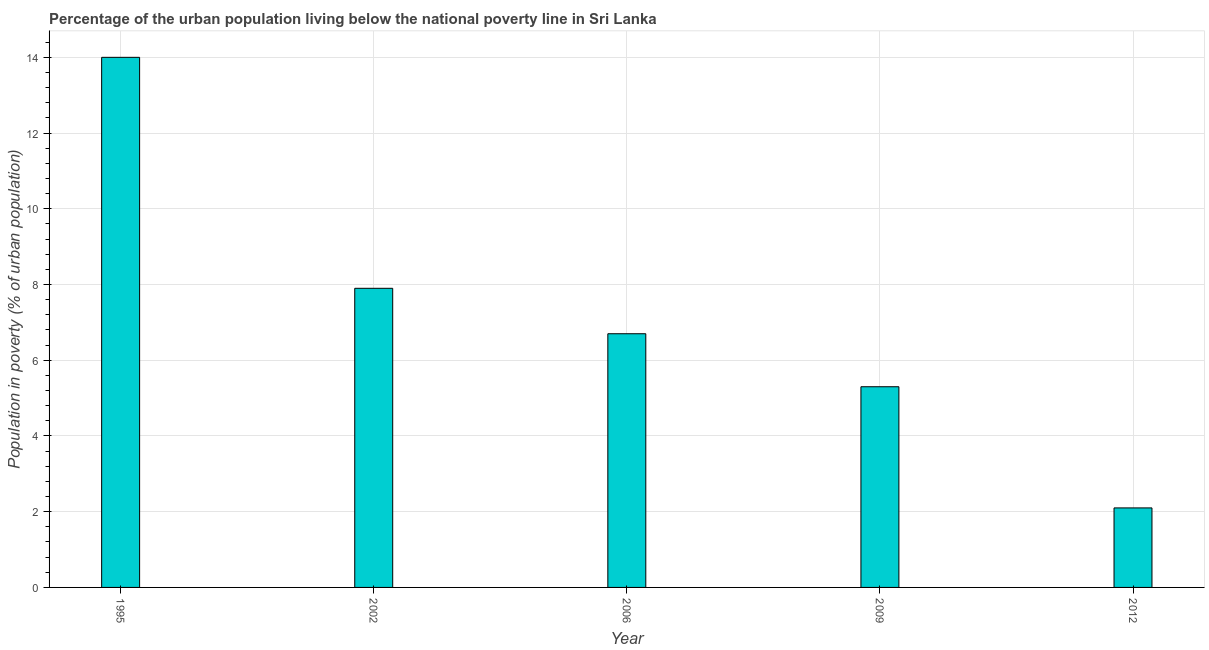What is the title of the graph?
Ensure brevity in your answer.  Percentage of the urban population living below the national poverty line in Sri Lanka. What is the label or title of the Y-axis?
Give a very brief answer. Population in poverty (% of urban population). What is the percentage of urban population living below poverty line in 2002?
Give a very brief answer. 7.9. Across all years, what is the maximum percentage of urban population living below poverty line?
Offer a terse response. 14. In which year was the percentage of urban population living below poverty line maximum?
Offer a very short reply. 1995. In which year was the percentage of urban population living below poverty line minimum?
Your response must be concise. 2012. What is the sum of the percentage of urban population living below poverty line?
Provide a succinct answer. 36. What is the median percentage of urban population living below poverty line?
Your response must be concise. 6.7. What is the ratio of the percentage of urban population living below poverty line in 2002 to that in 2009?
Keep it short and to the point. 1.49. Is the percentage of urban population living below poverty line in 1995 less than that in 2009?
Your answer should be very brief. No. Is the difference between the percentage of urban population living below poverty line in 2009 and 2012 greater than the difference between any two years?
Offer a terse response. No. What is the difference between the highest and the second highest percentage of urban population living below poverty line?
Make the answer very short. 6.1. Is the sum of the percentage of urban population living below poverty line in 2006 and 2009 greater than the maximum percentage of urban population living below poverty line across all years?
Provide a succinct answer. No. In how many years, is the percentage of urban population living below poverty line greater than the average percentage of urban population living below poverty line taken over all years?
Your answer should be very brief. 2. Are the values on the major ticks of Y-axis written in scientific E-notation?
Your response must be concise. No. What is the Population in poverty (% of urban population) of 1995?
Your answer should be very brief. 14. What is the Population in poverty (% of urban population) in 2002?
Ensure brevity in your answer.  7.9. What is the Population in poverty (% of urban population) in 2012?
Keep it short and to the point. 2.1. What is the difference between the Population in poverty (% of urban population) in 1995 and 2002?
Your answer should be compact. 6.1. What is the difference between the Population in poverty (% of urban population) in 1995 and 2006?
Make the answer very short. 7.3. What is the difference between the Population in poverty (% of urban population) in 1995 and 2009?
Give a very brief answer. 8.7. What is the difference between the Population in poverty (% of urban population) in 1995 and 2012?
Provide a short and direct response. 11.9. What is the difference between the Population in poverty (% of urban population) in 2002 and 2006?
Keep it short and to the point. 1.2. What is the difference between the Population in poverty (% of urban population) in 2006 and 2009?
Give a very brief answer. 1.4. What is the difference between the Population in poverty (% of urban population) in 2006 and 2012?
Ensure brevity in your answer.  4.6. What is the ratio of the Population in poverty (% of urban population) in 1995 to that in 2002?
Provide a succinct answer. 1.77. What is the ratio of the Population in poverty (% of urban population) in 1995 to that in 2006?
Ensure brevity in your answer.  2.09. What is the ratio of the Population in poverty (% of urban population) in 1995 to that in 2009?
Provide a short and direct response. 2.64. What is the ratio of the Population in poverty (% of urban population) in 1995 to that in 2012?
Provide a short and direct response. 6.67. What is the ratio of the Population in poverty (% of urban population) in 2002 to that in 2006?
Offer a terse response. 1.18. What is the ratio of the Population in poverty (% of urban population) in 2002 to that in 2009?
Provide a short and direct response. 1.49. What is the ratio of the Population in poverty (% of urban population) in 2002 to that in 2012?
Provide a short and direct response. 3.76. What is the ratio of the Population in poverty (% of urban population) in 2006 to that in 2009?
Make the answer very short. 1.26. What is the ratio of the Population in poverty (% of urban population) in 2006 to that in 2012?
Provide a short and direct response. 3.19. What is the ratio of the Population in poverty (% of urban population) in 2009 to that in 2012?
Your answer should be very brief. 2.52. 